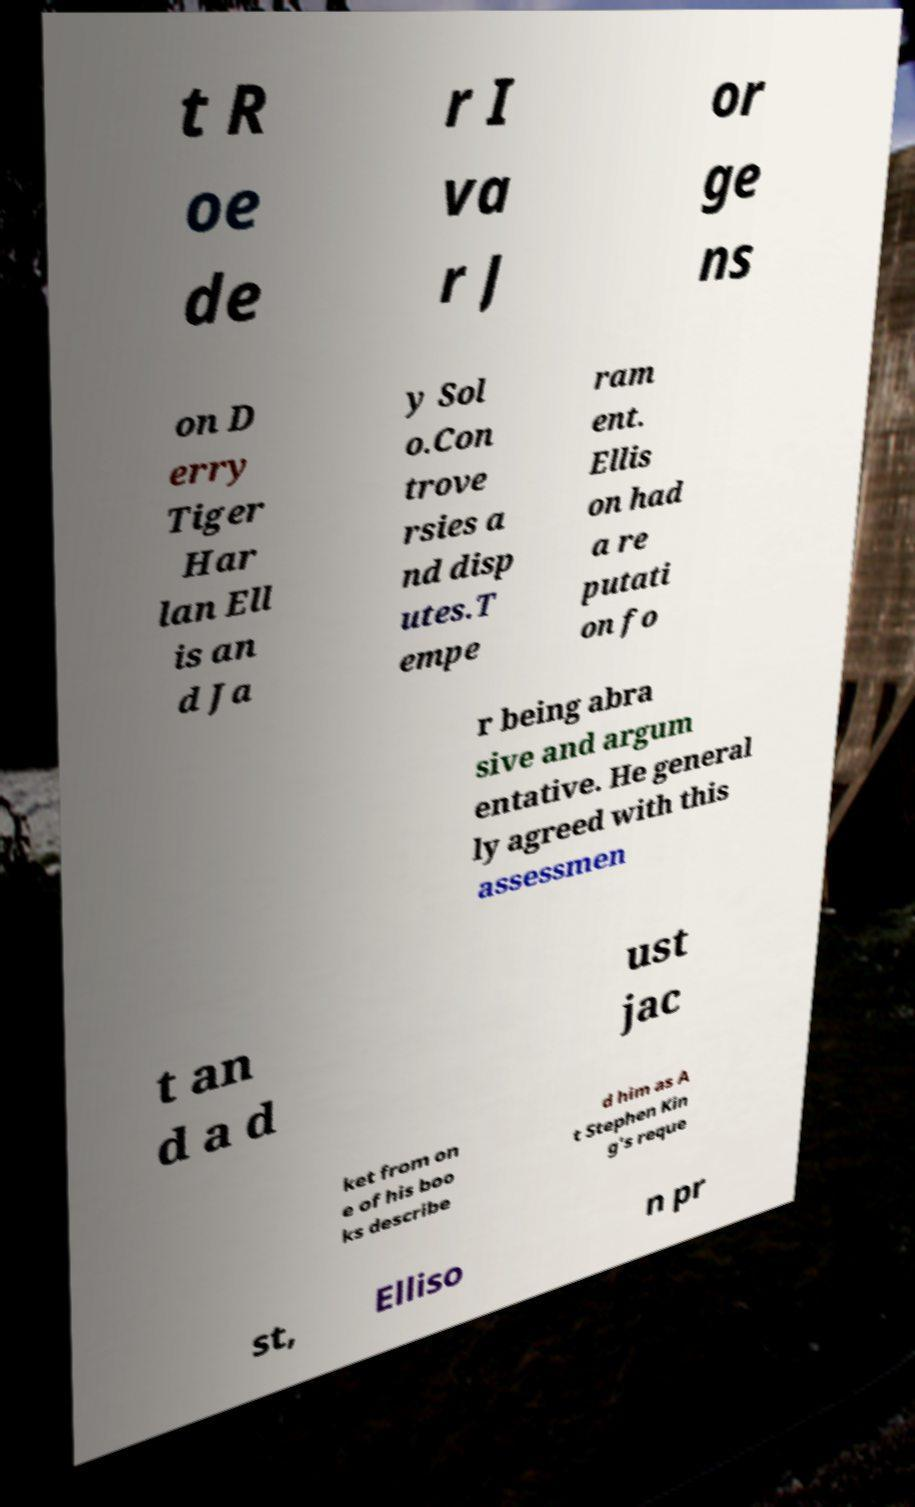There's text embedded in this image that I need extracted. Can you transcribe it verbatim? t R oe de r I va r J or ge ns on D erry Tiger Har lan Ell is an d Ja y Sol o.Con trove rsies a nd disp utes.T empe ram ent. Ellis on had a re putati on fo r being abra sive and argum entative. He general ly agreed with this assessmen t an d a d ust jac ket from on e of his boo ks describe d him as A t Stephen Kin g's reque st, Elliso n pr 